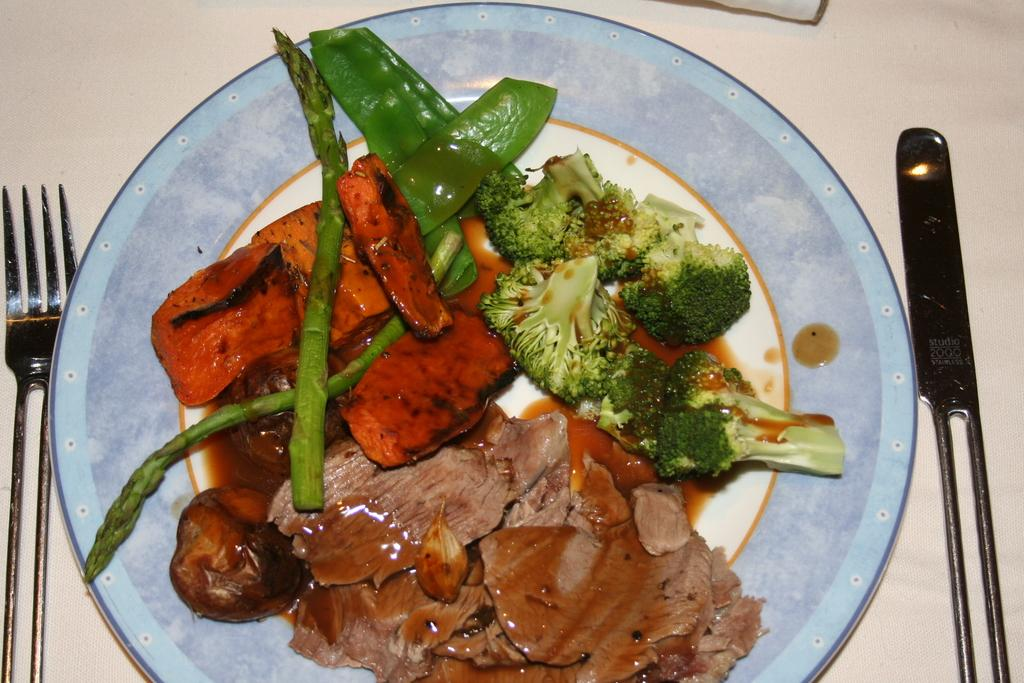What is located in the center of the image? There is a table in the center of the image. What is placed on the table? There is a plate of food items on the table. What utensils are present on the table? A fork and a knife are present on the table. What type of addition problem can be solved using the food items on the table? There is no addition problem present in the image, as it features a table with food items and utensils. 